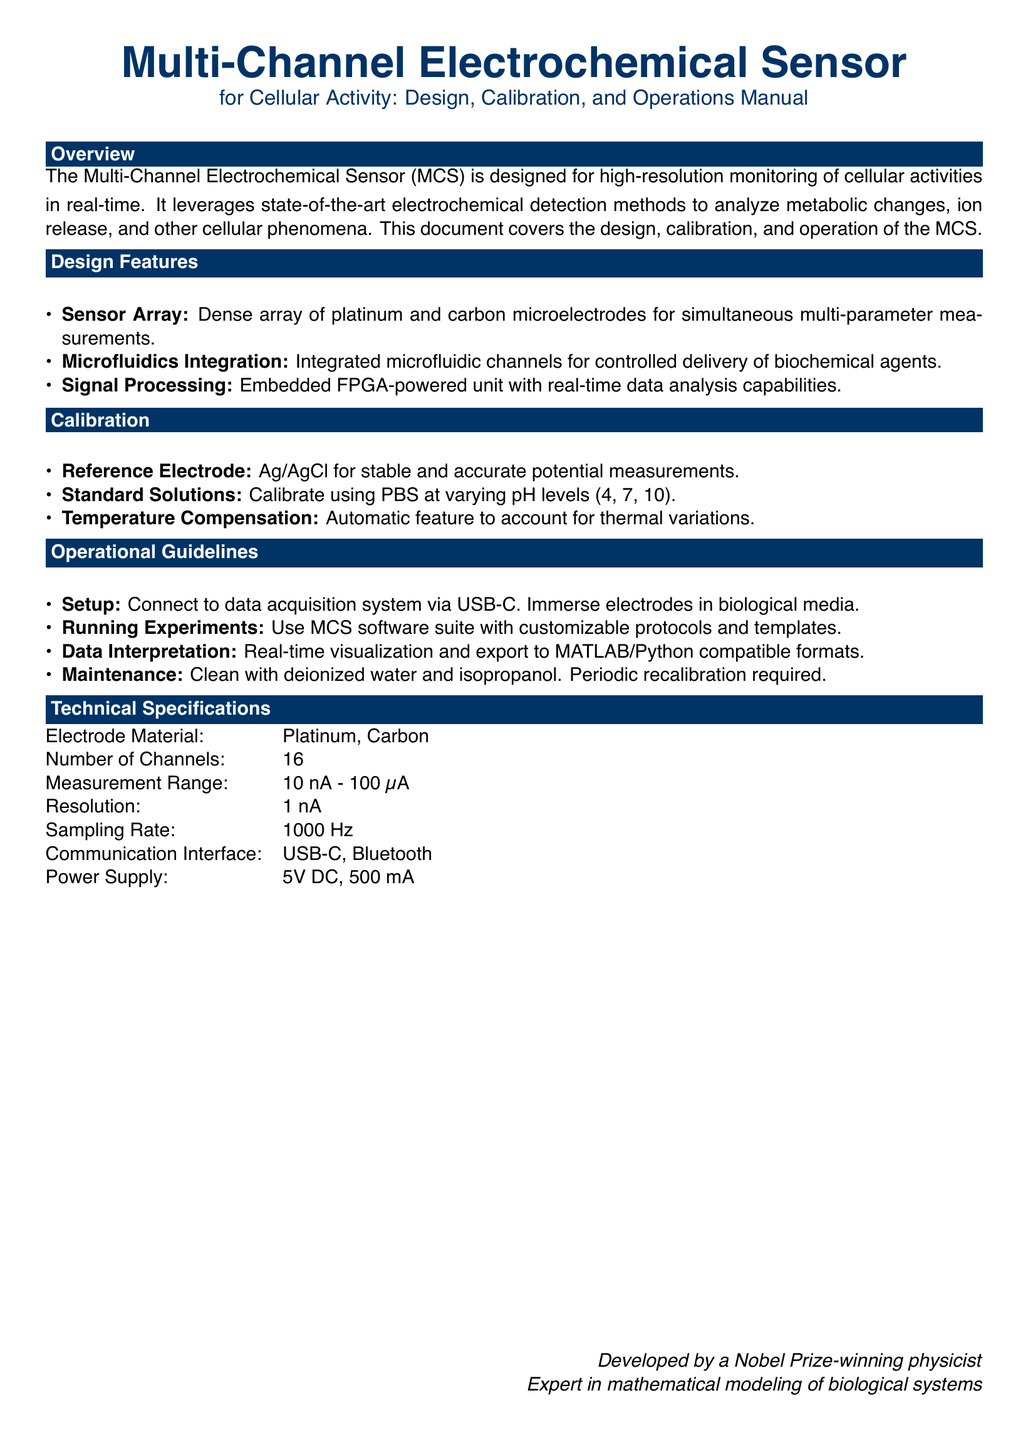What are the electrode materials used? The materials listed in the document for the electrodes are Platinum and Carbon.
Answer: Platinum, Carbon How many channels does the sensor have? The document states that the number of channels is 16.
Answer: 16 What is the sampling rate of the sensor? The sampling rate mentioned in the technical specifications is 1000 Hz.
Answer: 1000 Hz What type of communication interface does the sensor use? The document specifies the communication interface as USB-C and Bluetooth.
Answer: USB-C, Bluetooth What is the measurement range of the sensor? The document details the measurement range as 10 nA - 100 µA.
Answer: 10 nA - 100 µA Why is temperature compensation included in the calibration? The automatic temperature compensation accounts for thermal variations affecting measurements.
Answer: Thermal variations What is the purpose of using Ag/AgCl as a reference electrode? It provides stable and accurate potential measurements for the sensor.
Answer: Stable and accurate potential measurements How should the sensor be maintained? The maintenance instructions indicate cleaning with deionized water and isopropanol, along with periodic recalibration.
Answer: Clean with deionized water and isopropanol What software suite is recommended for running experiments? The document refers to a customizable MCS software suite for experiments.
Answer: MCS software suite 